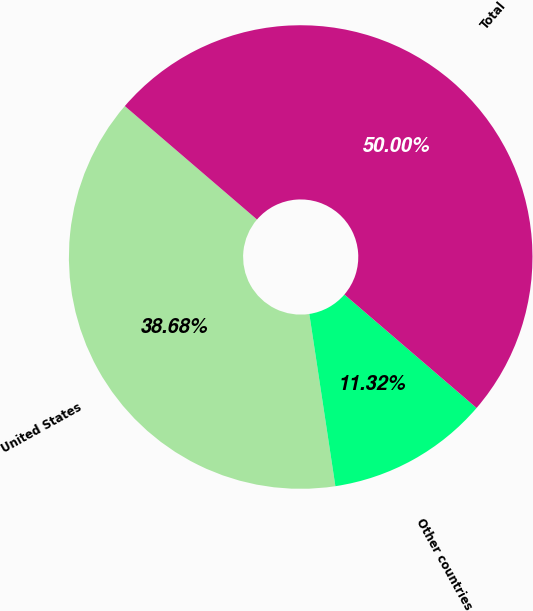Convert chart to OTSL. <chart><loc_0><loc_0><loc_500><loc_500><pie_chart><fcel>United States<fcel>Other countries<fcel>Total<nl><fcel>38.68%<fcel>11.32%<fcel>50.0%<nl></chart> 